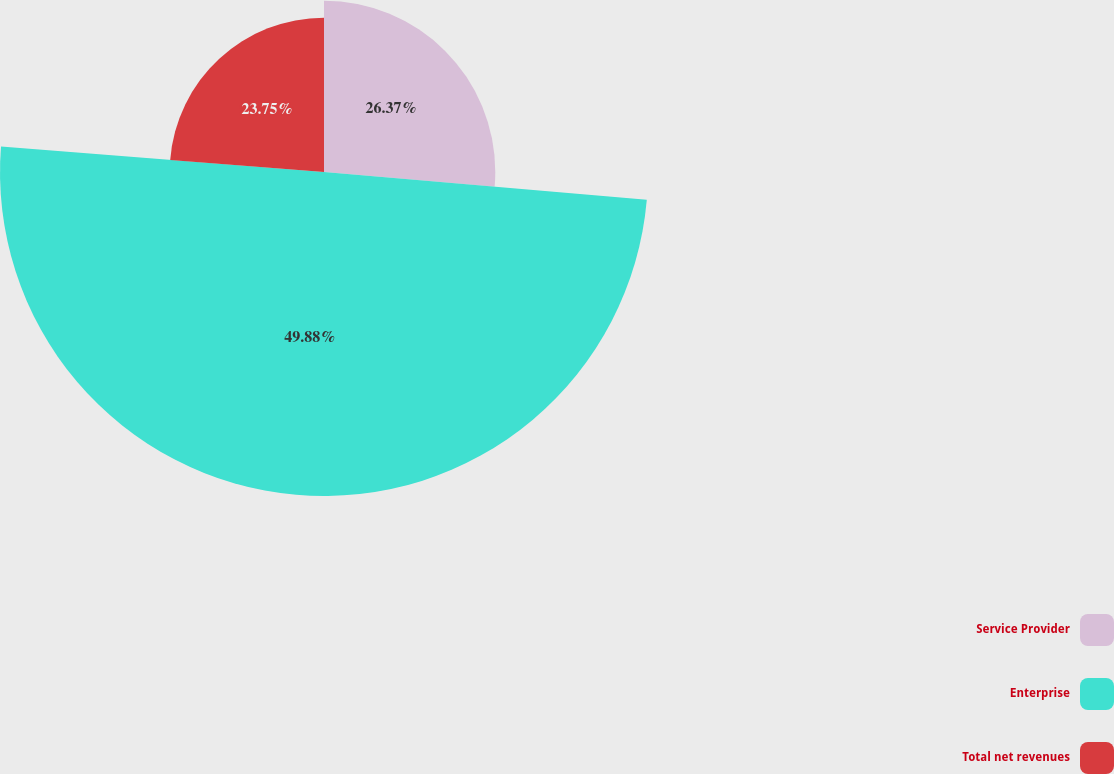Convert chart. <chart><loc_0><loc_0><loc_500><loc_500><pie_chart><fcel>Service Provider<fcel>Enterprise<fcel>Total net revenues<nl><fcel>26.37%<fcel>49.88%<fcel>23.75%<nl></chart> 